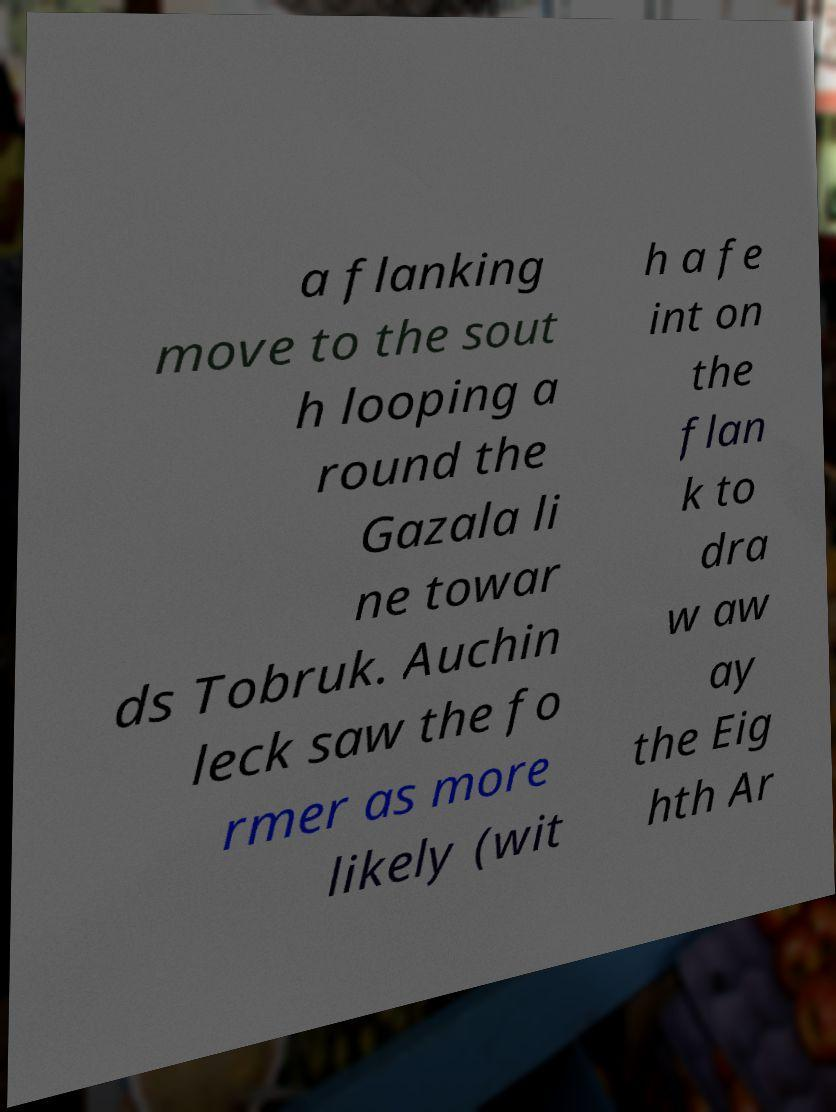Could you extract and type out the text from this image? a flanking move to the sout h looping a round the Gazala li ne towar ds Tobruk. Auchin leck saw the fo rmer as more likely (wit h a fe int on the flan k to dra w aw ay the Eig hth Ar 